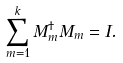Convert formula to latex. <formula><loc_0><loc_0><loc_500><loc_500>\sum _ { m = 1 } ^ { k } M _ { m } ^ { \dagger } M _ { m } = I .</formula> 